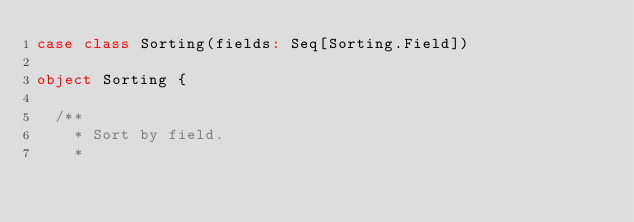<code> <loc_0><loc_0><loc_500><loc_500><_Scala_>case class Sorting(fields: Seq[Sorting.Field])

object Sorting {

  /**
    * Sort by field.
    *</code> 